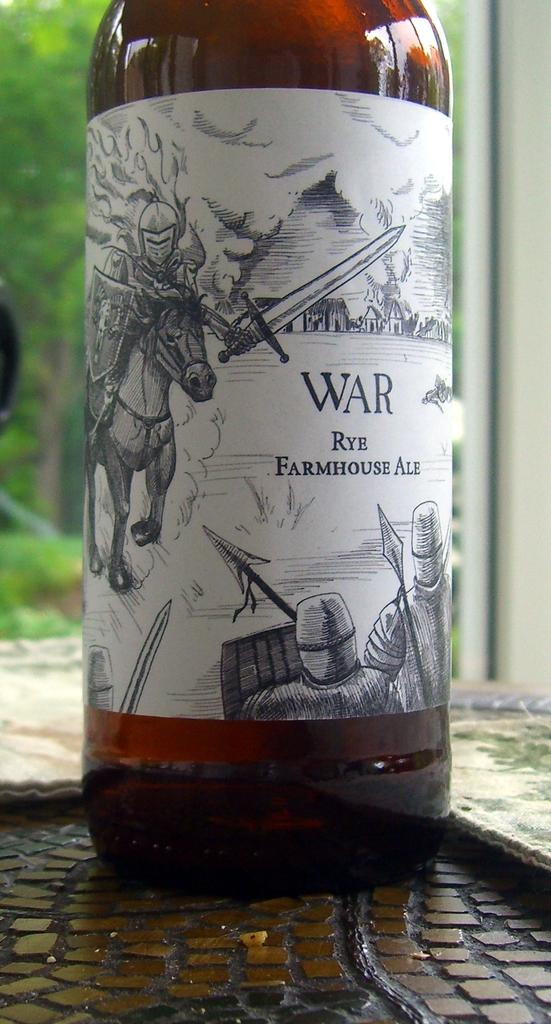<image>
Describe the image concisely. A bottle of War Rye Farmhouse ale by a window and with scene of a medieval war on its label. 